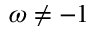<formula> <loc_0><loc_0><loc_500><loc_500>\omega \neq - 1</formula> 